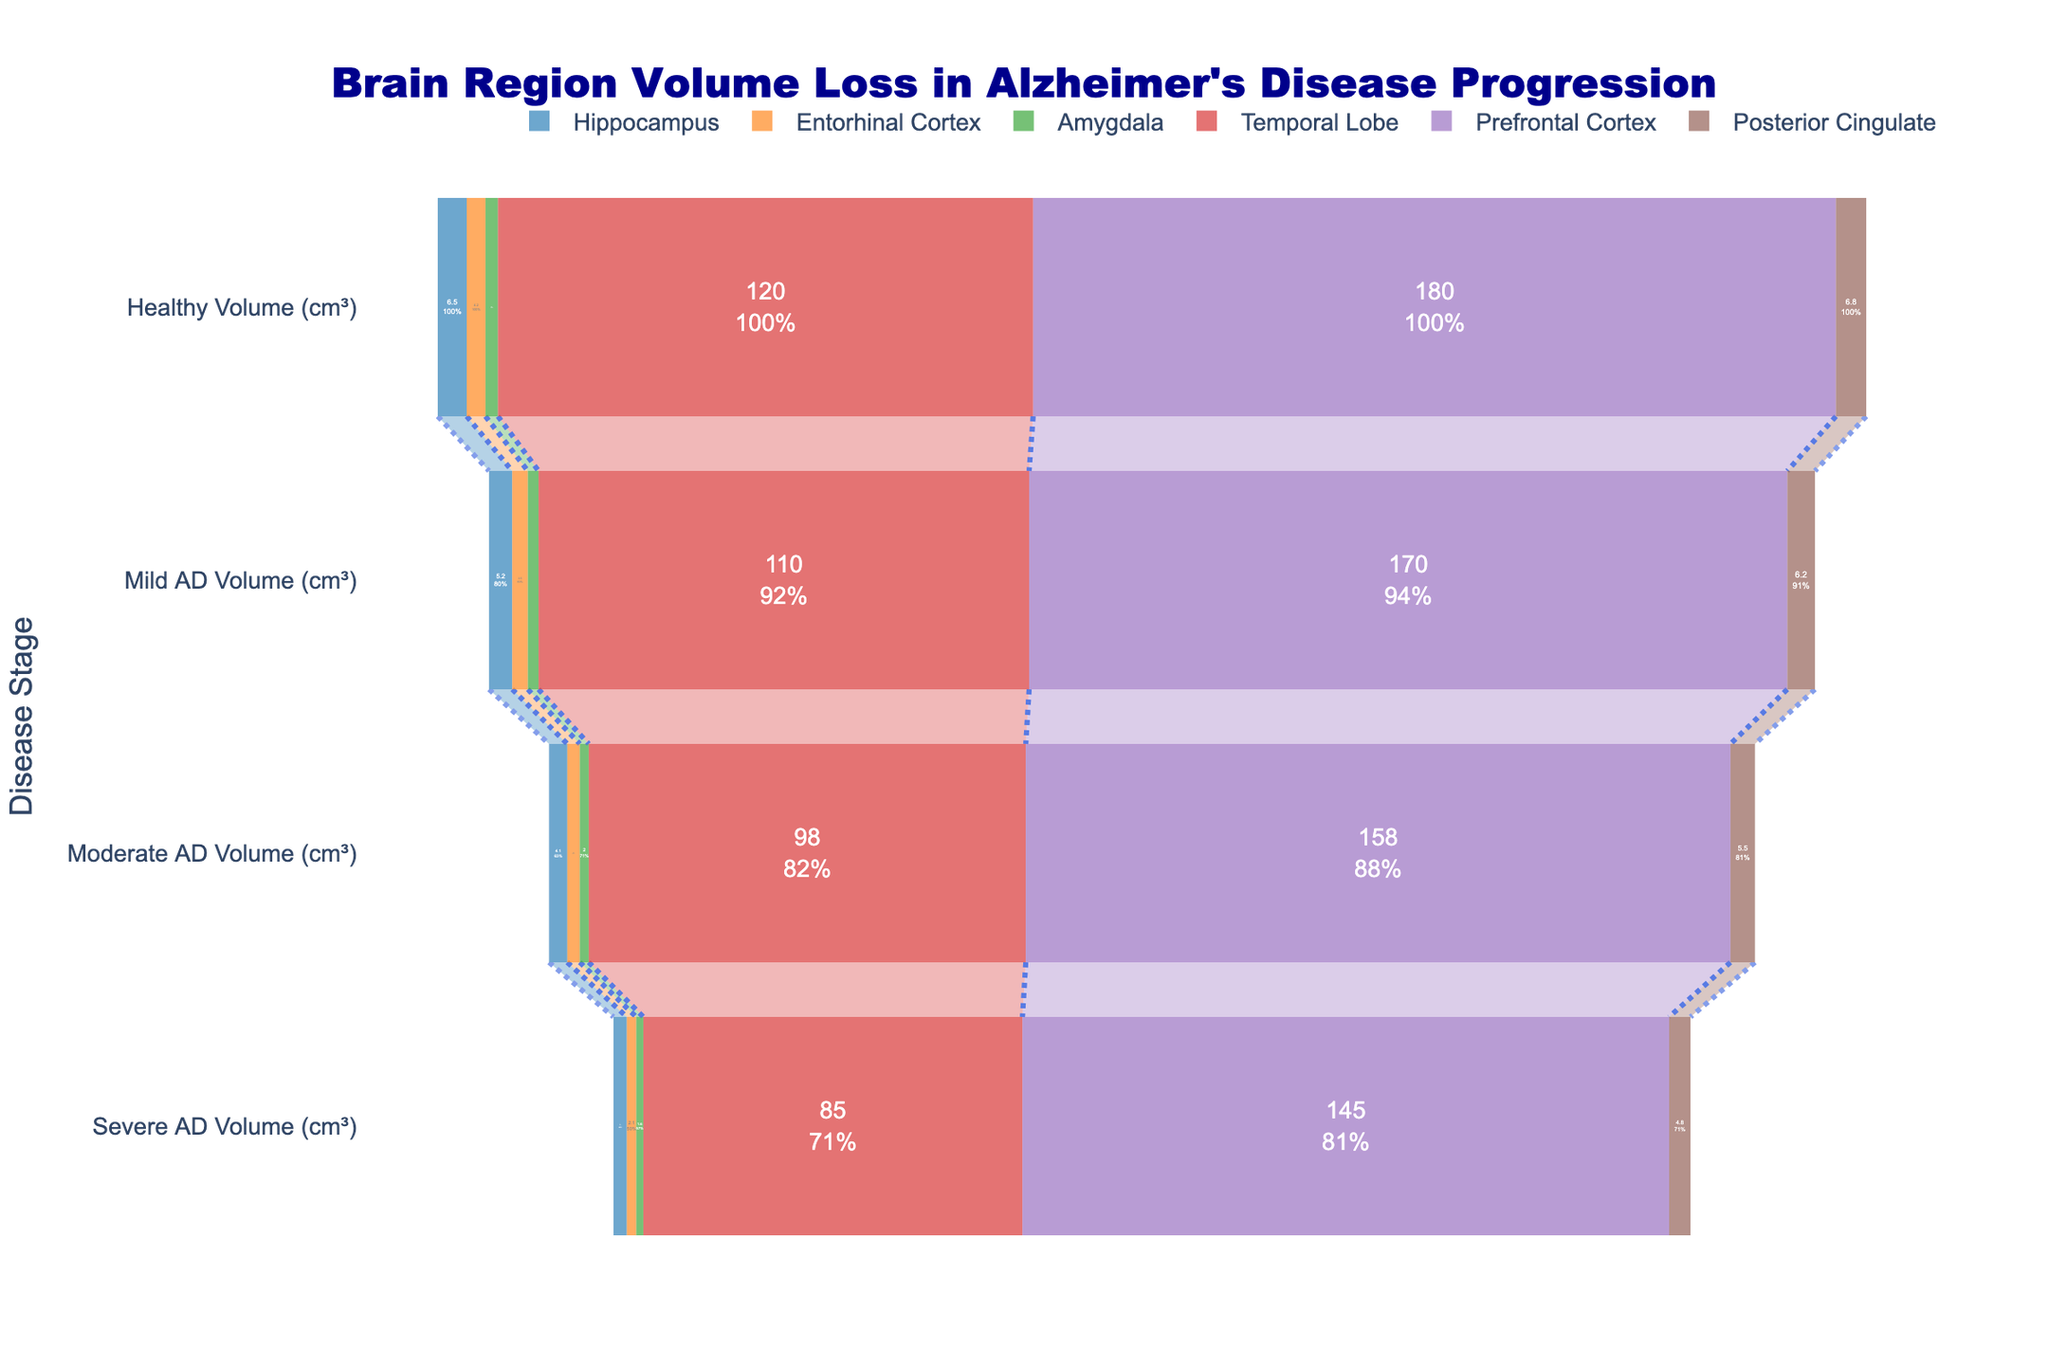What is the title of the funnel chart? The title is the text prominently displayed at the top of the chart. In this chart, the title specifically provides context about the representation of brain region volume loss in Alzheimer's Disease progression.
Answer: Brain Region Volume Loss in Alzheimer's Disease Progression What are the stages represented on the y-axis of the funnel chart? The stages on the y-axis indicate the different levels of Alzheimer's Disease severity. These stages are listed from top to bottom and are labelled accordingly.
Answer: Healthy Volume (cm³), Mild AD Volume (cm³), Moderate AD Volume (cm³), Severe AD Volume (cm³) Which brain region shows the greatest volume loss from the Healthy stage to the Severe AD stage? To determine this, observe the starting and ending points of each funnel corresponding to each brain region. The region with the largest difference between the Healthy and Severe AD stages represents the greatest volume loss.
Answer: Temporal Lobe Compare the volume loss of the Hippocampus and the Amygdala in the Mild AD stage. Which region has experienced less volume loss compared to the Healthy stage? Refer to the values of the Mild AD volumes for both regions and compare them to their respective Healthy stage volumes. The region with a higher remaining volume in the Mild AD stage has experienced less loss.
Answer: Amygdala What percentage of the Prefrontal Cortex's volume is lost when transitioning from the Healthy stage to the Moderate AD stage? First, calculate the reduction in volume (Healthy volume - Moderate AD volume). Then, find the percentage reduction by dividing by the Healthy volume and multiplying by 100. Prefrontal Cortex: (180 - 158) / 180 * 100.
Answer: 12.2% Which brain region has the smallest volume at the Severe AD stage? Examine the funnel endpoints at the Severe AD stage for each brain region. The region with the smallest value is the one with the smallest volume.
Answer: Amygdala Are the volume losses consistent across all stages for each brain region? Check the volume reductions stage-by-stage for each brain region and determine if the losses are uniform or vary. Consistent losses would show a similar decrease at each stage.
Answer: No, volume losses vary across stages How does the volume of the Posterior Cingulate in the Moderate AD stage compare to the Entorhinal Cortex in the same stage? Look at the volumes for both regions in the Moderate AD stage and directly compare the values given.
Answer: The volume of Posterior Cingulate is larger What trends can be observed in the volume loss of the Temporal Lobe compared to other brain regions? Analyze the data for each stage and observe if the Temporal Lobe consistently loses more or less volume than other regions across all stages.
Answer: The Temporal Lobe shows significant volume loss through all stages, larger than most other regions Calculate the average volume loss for the Hippocampus across all stages from Healthy to Severe AD. First, calculate the volume loss at each stage. Sum the total losses and then divide by the number of transitions (3: Healthy to Mild, Mild to Moderate, Moderate to Severe). (6.5-5.2) + (5.2-4.1) + (4.1-3.0) = 1.3 + 1.1 + 1.1. Average = (1.3 + 1.1 + 1.1) / 3.
Answer: 1.17 cm³ 